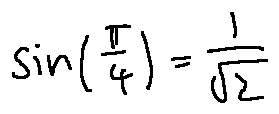Convert formula to latex. <formula><loc_0><loc_0><loc_500><loc_500>\sin ( \frac { \pi } { 4 } ) = \frac { 1 } { \sqrt { 2 } }</formula> 